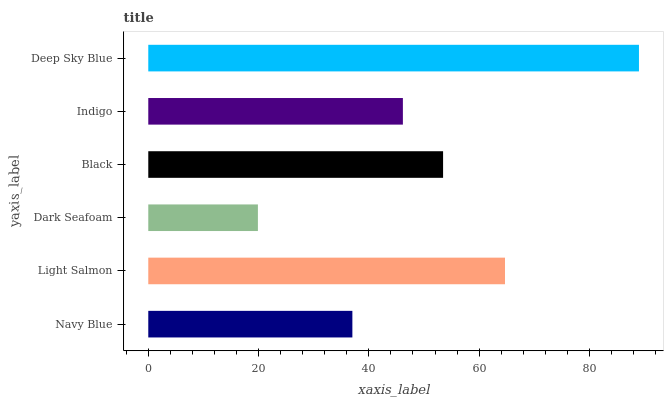Is Dark Seafoam the minimum?
Answer yes or no. Yes. Is Deep Sky Blue the maximum?
Answer yes or no. Yes. Is Light Salmon the minimum?
Answer yes or no. No. Is Light Salmon the maximum?
Answer yes or no. No. Is Light Salmon greater than Navy Blue?
Answer yes or no. Yes. Is Navy Blue less than Light Salmon?
Answer yes or no. Yes. Is Navy Blue greater than Light Salmon?
Answer yes or no. No. Is Light Salmon less than Navy Blue?
Answer yes or no. No. Is Black the high median?
Answer yes or no. Yes. Is Indigo the low median?
Answer yes or no. Yes. Is Navy Blue the high median?
Answer yes or no. No. Is Dark Seafoam the low median?
Answer yes or no. No. 